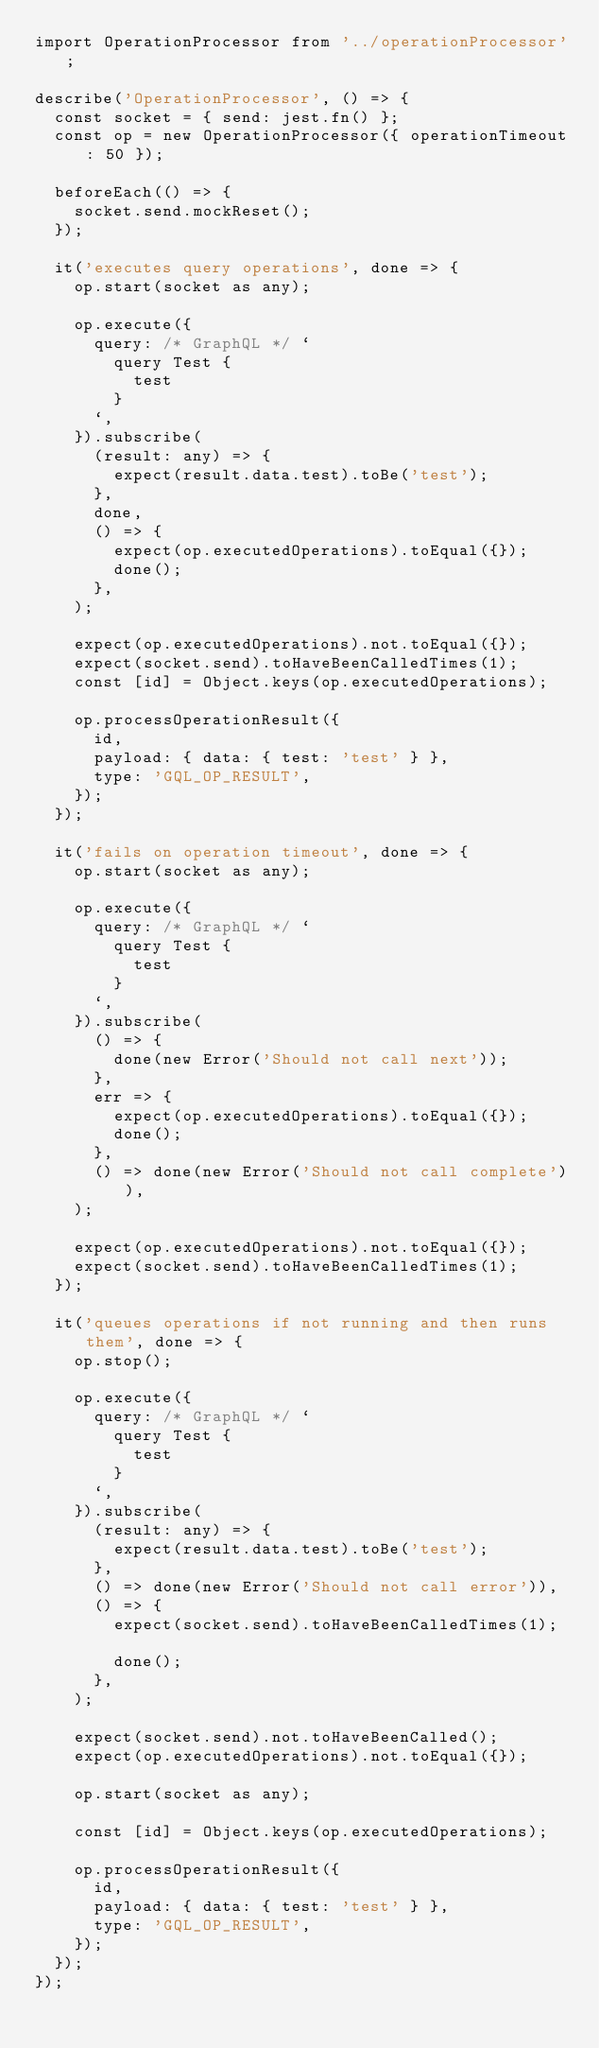<code> <loc_0><loc_0><loc_500><loc_500><_TypeScript_>import OperationProcessor from '../operationProcessor';

describe('OperationProcessor', () => {
  const socket = { send: jest.fn() };
  const op = new OperationProcessor({ operationTimeout: 50 });

  beforeEach(() => {
    socket.send.mockReset();
  });

  it('executes query operations', done => {
    op.start(socket as any);

    op.execute({
      query: /* GraphQL */ `
        query Test {
          test
        }
      `,
    }).subscribe(
      (result: any) => {
        expect(result.data.test).toBe('test');
      },
      done,
      () => {
        expect(op.executedOperations).toEqual({});
        done();
      },
    );

    expect(op.executedOperations).not.toEqual({});
    expect(socket.send).toHaveBeenCalledTimes(1);
    const [id] = Object.keys(op.executedOperations);

    op.processOperationResult({
      id,
      payload: { data: { test: 'test' } },
      type: 'GQL_OP_RESULT',
    });
  });

  it('fails on operation timeout', done => {
    op.start(socket as any);

    op.execute({
      query: /* GraphQL */ `
        query Test {
          test
        }
      `,
    }).subscribe(
      () => {
        done(new Error('Should not call next'));
      },
      err => {
        expect(op.executedOperations).toEqual({});
        done();
      },
      () => done(new Error('Should not call complete')),
    );

    expect(op.executedOperations).not.toEqual({});
    expect(socket.send).toHaveBeenCalledTimes(1);
  });

  it('queues operations if not running and then runs them', done => {
    op.stop();

    op.execute({
      query: /* GraphQL */ `
        query Test {
          test
        }
      `,
    }).subscribe(
      (result: any) => {
        expect(result.data.test).toBe('test');
      },
      () => done(new Error('Should not call error')),
      () => {
        expect(socket.send).toHaveBeenCalledTimes(1);

        done();
      },
    );

    expect(socket.send).not.toHaveBeenCalled();
    expect(op.executedOperations).not.toEqual({});

    op.start(socket as any);

    const [id] = Object.keys(op.executedOperations);

    op.processOperationResult({
      id,
      payload: { data: { test: 'test' } },
      type: 'GQL_OP_RESULT',
    });
  });
});
</code> 